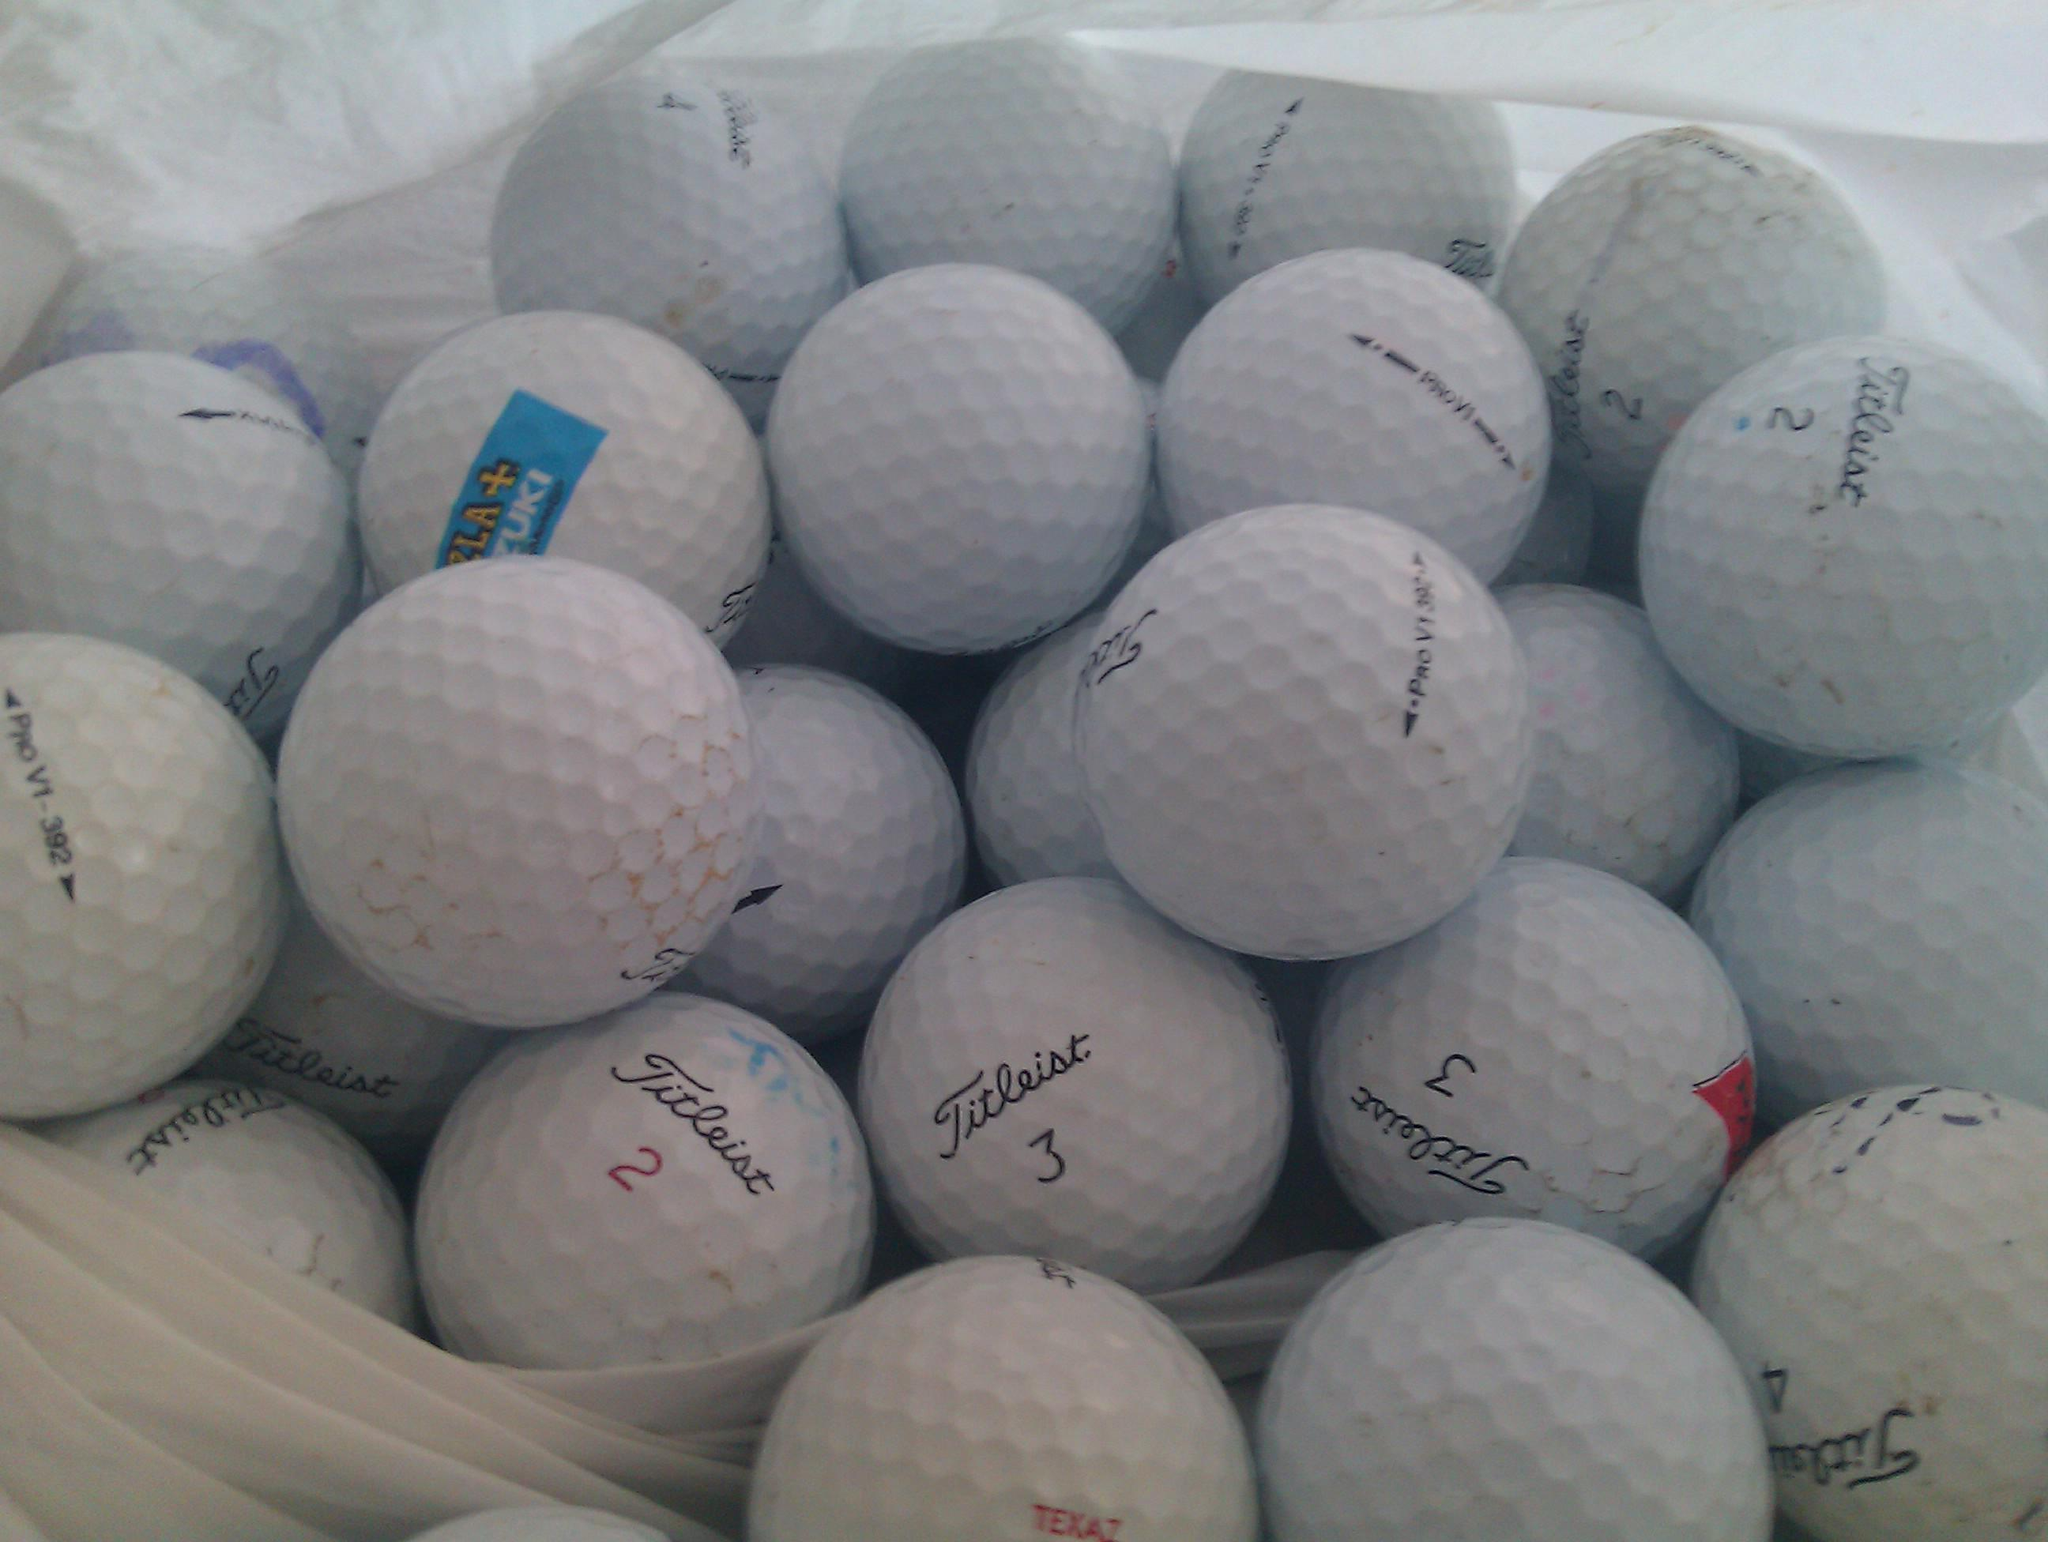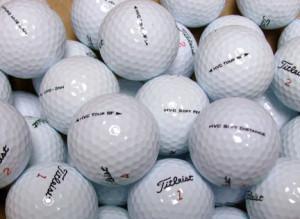The first image is the image on the left, the second image is the image on the right. Evaluate the accuracy of this statement regarding the images: "The golfballs in the image on the right are not in shadow.". Is it true? Answer yes or no. Yes. 